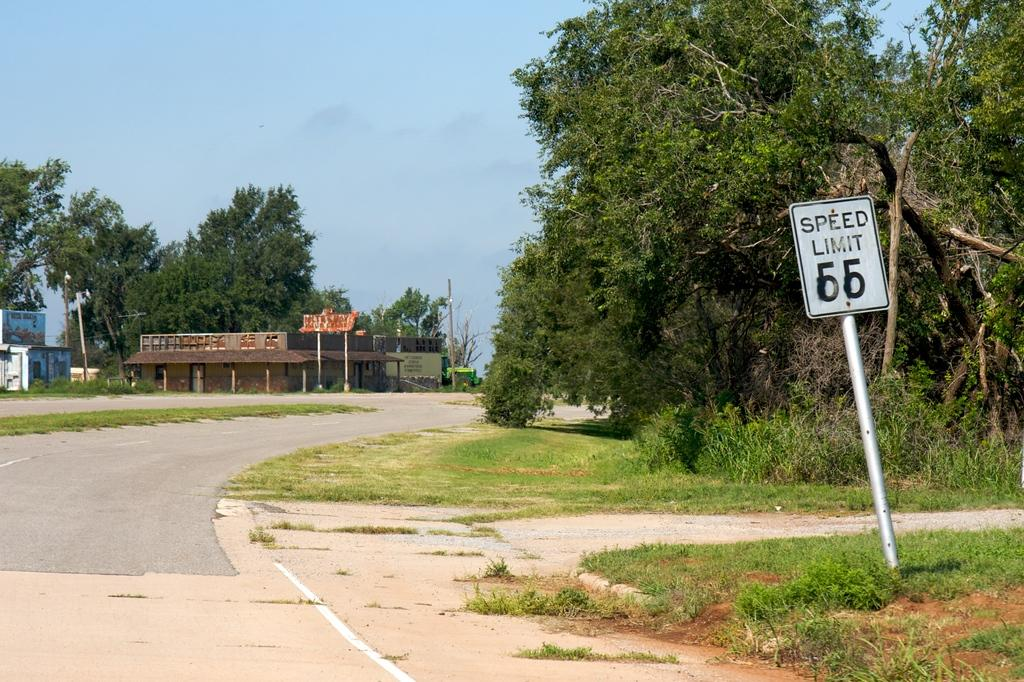What type of surface can be seen in the image? There is a road in the image. What type of vegetation is present in the image? There is grass and trees in the image. What type of structures can be seen in the image? There are houses in the image. What type of informational object is present in the image? There is a signboard in the image. What type of vertical structures can be seen in the image? There are poles in the image. What is visible in the background of the image? The sky is visible in the background of the image. Can you tell me how many zebras are walking on the road in the image? There are no zebras present in the image. What type of trade is happening between the houses in the image? There is no trade happening between the houses in the image; it is not mentioned in the provided facts. 